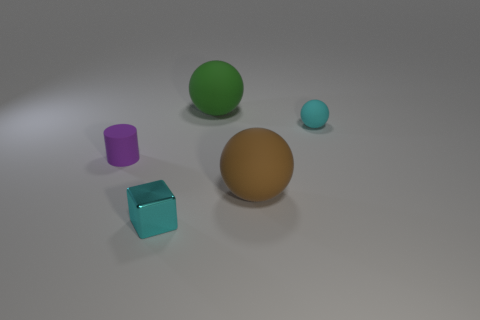Add 3 yellow metallic things. How many objects exist? 8 Subtract all balls. How many objects are left? 2 Add 5 brown rubber spheres. How many brown rubber spheres exist? 6 Subtract 0 yellow cubes. How many objects are left? 5 Subtract all big green matte balls. Subtract all tiny red cubes. How many objects are left? 4 Add 2 tiny cyan metallic objects. How many tiny cyan metallic objects are left? 3 